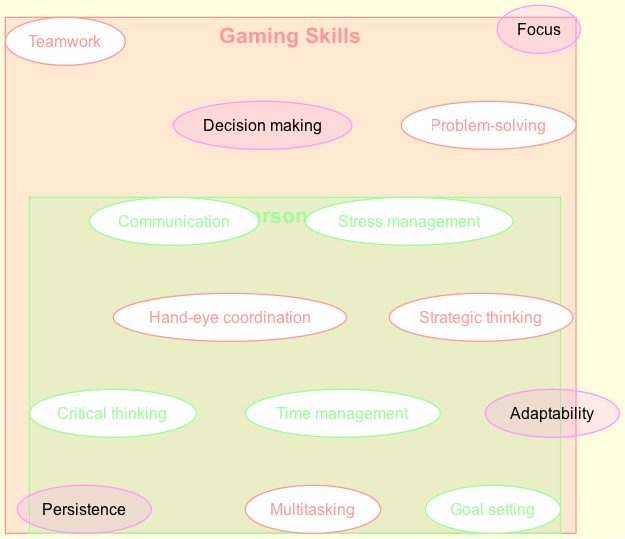What skills are unique to gaming? The diagram displays the set of skills under "Gaming Skills," which includes problem-solving, strategic thinking, hand-eye coordination, teamwork, and multitasking. From this set, the unique skills can be directly listed.
Answer: Problem-solving, strategic thinking, hand-eye coordination, teamwork, multitasking How many skills are in the "Academic & Personal Success Skills" set? The diagram shows a list of five skills in the "Academic & Personal Success Skills" set: time management, critical thinking, goal setting, communication, and stress management. Counting these gives the total number.
Answer: 5 What skill appears in both sets? The overlap section highlights skills that are common to both "Gaming Skills" and "Academic & Personal Success Skills." By identifying the skills listed in the overlap, we find the common skill.
Answer: Persistence, adaptability, focus, decision making Which skill is associated with managing pressure? In the "Academic & Personal Success Skills" set, the skill related to managing pressure is listed as stress management. This can be directly found in that set.
Answer: Stress management What is the total number of unique skills across all categories? To find the total unique skills, we count the individual skills in both sets and also include the skills mentioned in the overlap section. We sum these to find the overall unique skill count.
Answer: 10 Which skill is directly related to working with others? Examining the "Gaming Skills" set, teamwork is explicitly listed as a skill that involves collaboration with other players. This indicates the skill is associated with working with others.
Answer: Teamwork How many skills are in the overlapping area? The overlap section lists four skills: persistence, adaptability, focus, and decision making. By simply counting these skills, the number in the overlapping area can be determined.
Answer: 4 Which set includes critical thinking? Critical thinking is among the skills listed specifically in the "Academic & Personal Success Skills" set. It can be directly referenced by looking at the respective set.
Answer: Academic & Personal Success Skills What is the relationship between strategic thinking and goal setting? Strategic thinking is found in the "Gaming Skills" set, while goal setting is included in the "Academic & Personal Success Skills" set. This indicates that both skills are distinct but contribute to overall success.
Answer: Distinct but complementary 